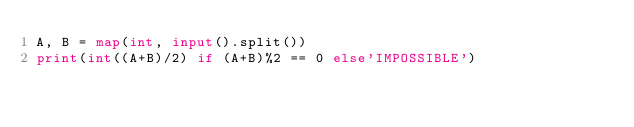Convert code to text. <code><loc_0><loc_0><loc_500><loc_500><_Python_>A, B = map(int, input().split())
print(int((A+B)/2) if (A+B)%2 == 0 else'IMPOSSIBLE')</code> 